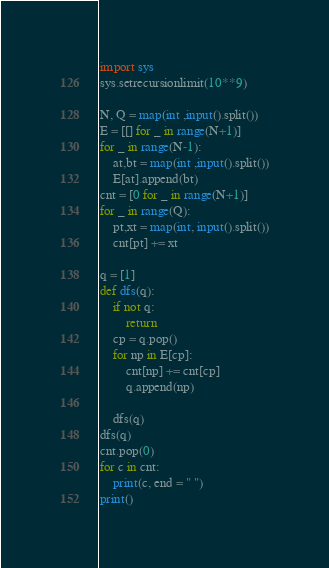Convert code to text. <code><loc_0><loc_0><loc_500><loc_500><_Python_>import sys
sys.setrecursionlimit(10**9)

N, Q = map(int ,input().split())
E = [[] for _ in range(N+1)]
for _ in range(N-1):
	at,bt = map(int ,input().split())
	E[at].append(bt)
cnt = [0 for _ in range(N+1)]
for _ in range(Q):
	pt,xt = map(int, input().split())
	cnt[pt] += xt

q = [1]
def dfs(q):
	if not q:
		return
	cp = q.pop()
	for np in E[cp]:
		cnt[np] += cnt[cp]
		q.append(np)

	dfs(q)
dfs(q)
cnt.pop(0)
for c in cnt:
	print(c, end = " ")
print()</code> 